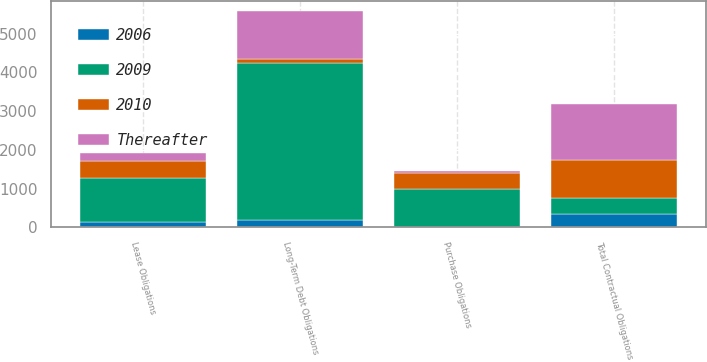<chart> <loc_0><loc_0><loc_500><loc_500><stacked_bar_chart><ecel><fcel>Long-Term Debt Obligations<fcel>Lease Obligations<fcel>Purchase Obligations<fcel>Total Contractual Obligations<nl><fcel>2009<fcel>4033<fcel>1150<fcel>992<fcel>418<nl><fcel>2010<fcel>119<fcel>438<fcel>418<fcel>975<nl><fcel>Thereafter<fcel>1222<fcel>190<fcel>28<fcel>1440<nl><fcel>2006<fcel>200<fcel>134<fcel>3<fcel>337<nl></chart> 